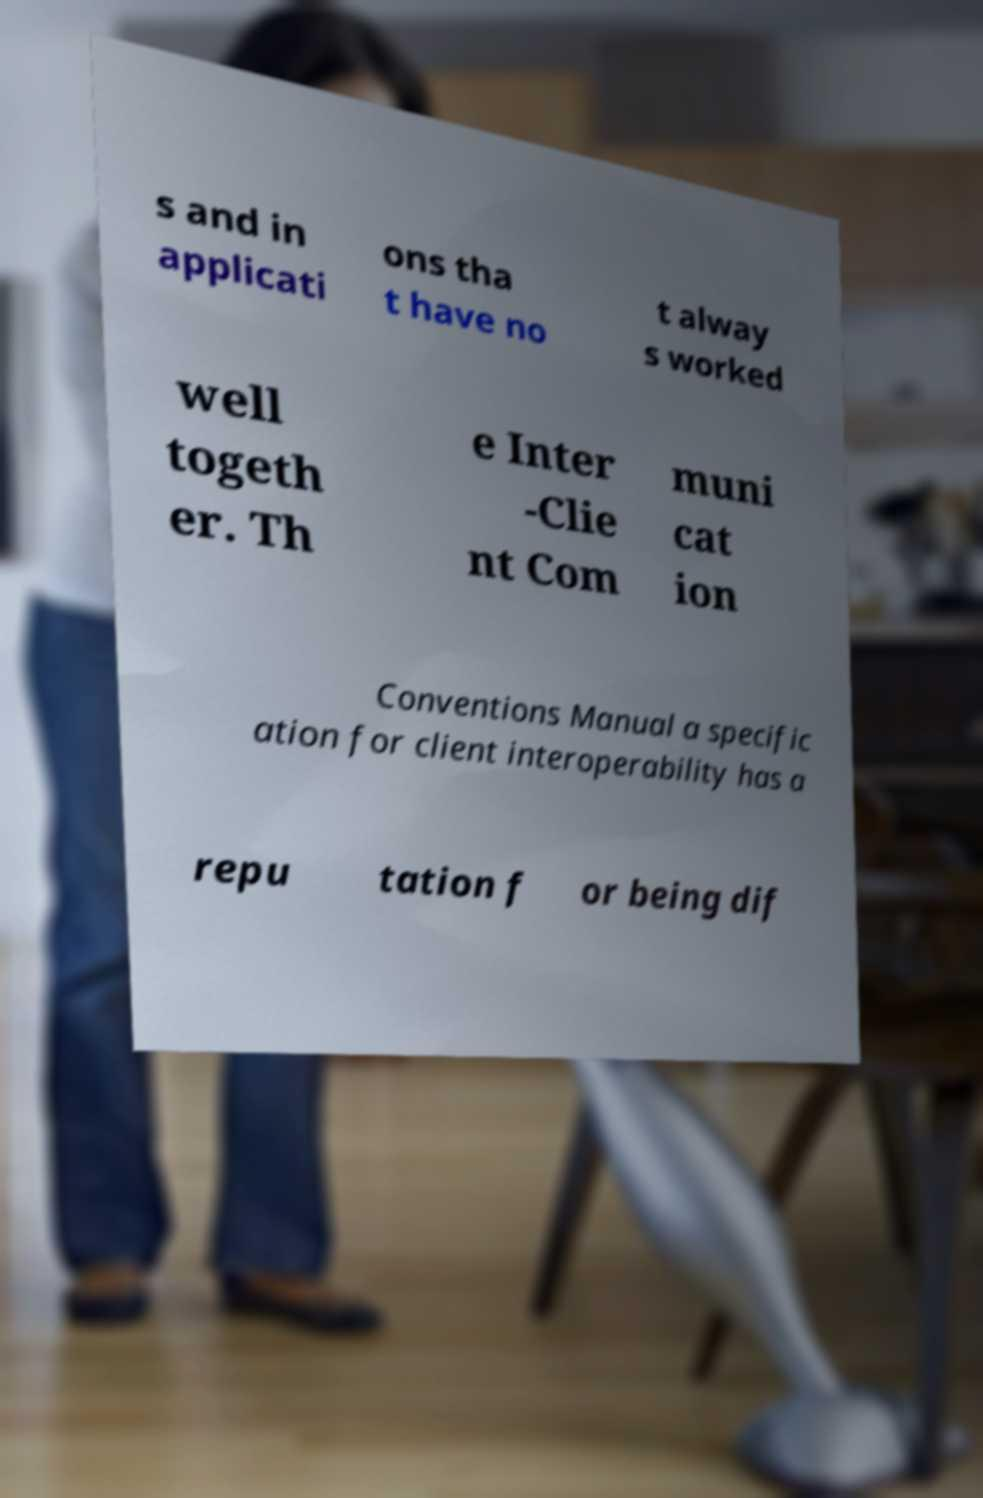Can you accurately transcribe the text from the provided image for me? s and in applicati ons tha t have no t alway s worked well togeth er. Th e Inter -Clie nt Com muni cat ion Conventions Manual a specific ation for client interoperability has a repu tation f or being dif 